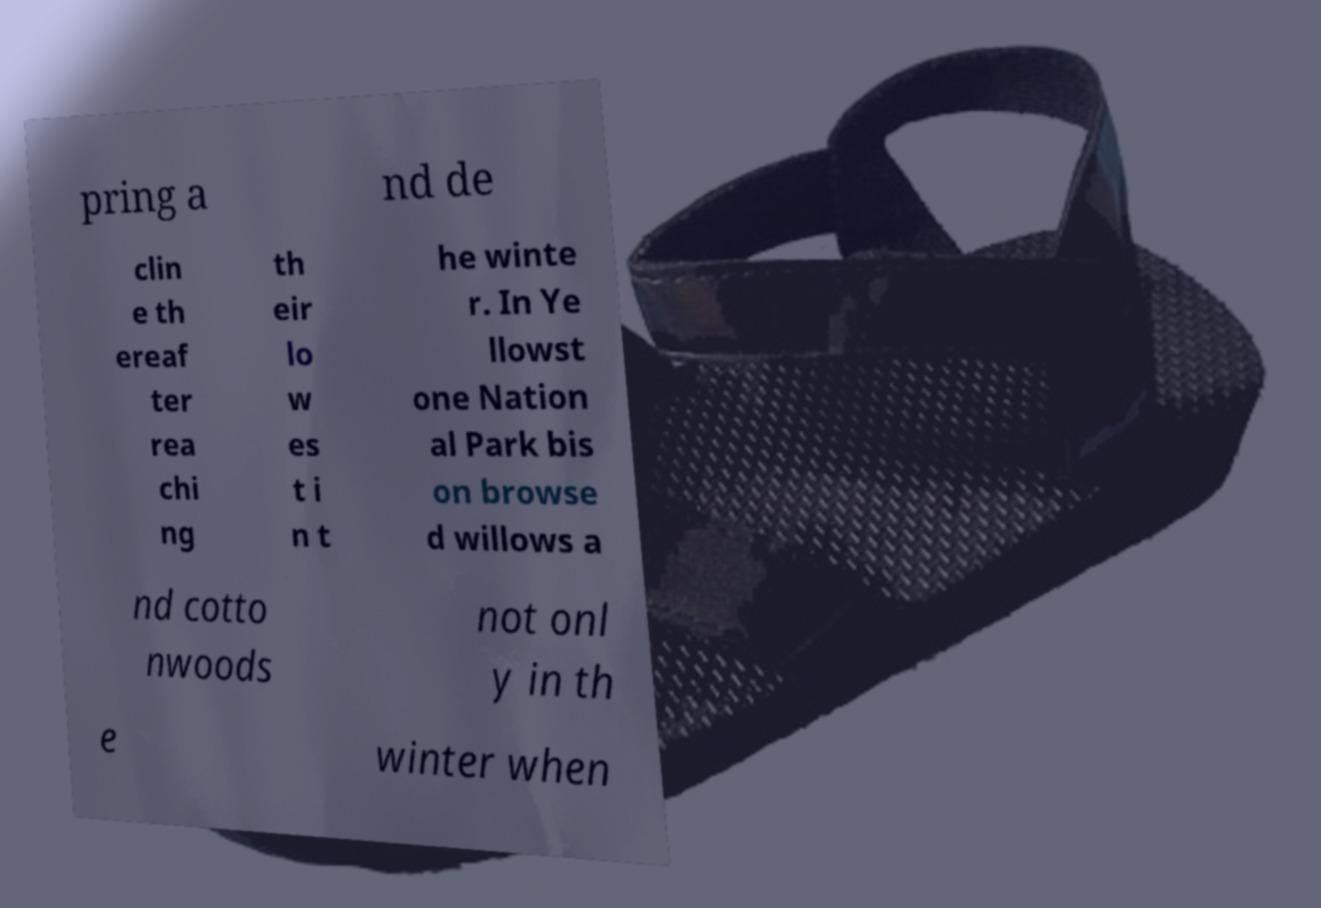For documentation purposes, I need the text within this image transcribed. Could you provide that? pring a nd de clin e th ereaf ter rea chi ng th eir lo w es t i n t he winte r. In Ye llowst one Nation al Park bis on browse d willows a nd cotto nwoods not onl y in th e winter when 